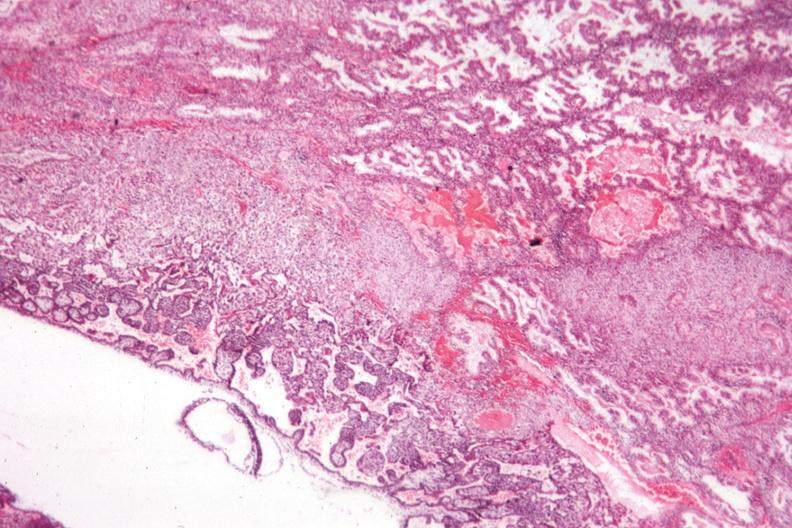s female reproductive present?
Answer the question using a single word or phrase. Yes 